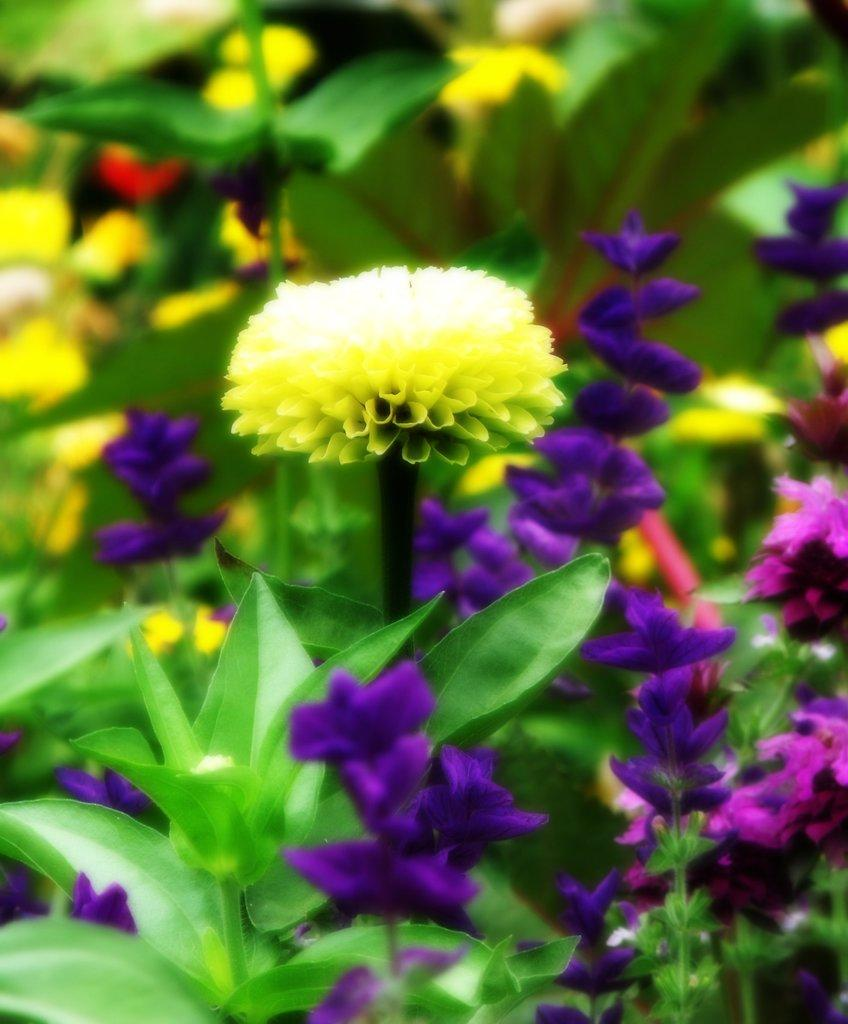What can be observed about the image itself? The image is edited. What type of natural elements are present in the image? There are plants and flowers in the image. What type of card can be seen being used to fan the heat in the image? There is no card or heat present in the image; it features plants and flowers. 